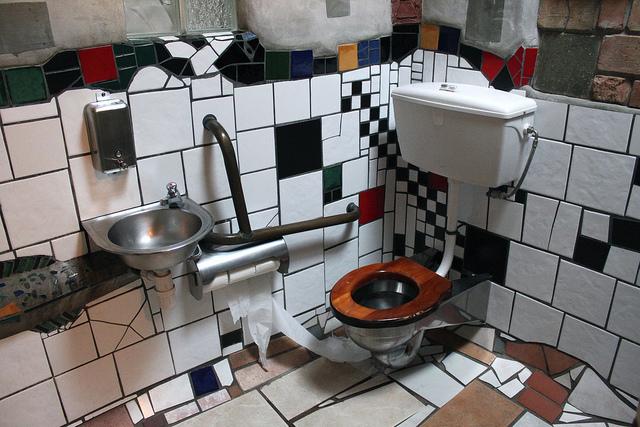What type of room is this?
Quick response, please. Bathroom. What color is the toilet seat?
Keep it brief. Brown. Are the tiles all square?
Give a very brief answer. No. 